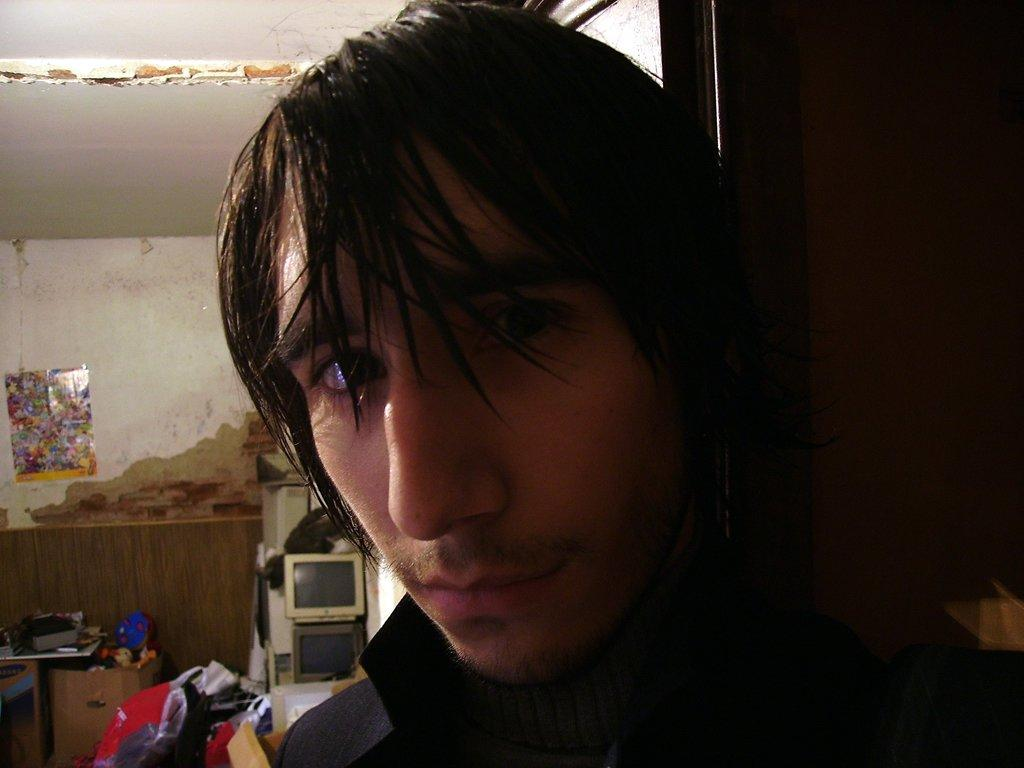Who or what is the main subject in the image? There is a person in the image. What can be seen in the background of the image? There are televisions, a cover bag, a table, a wall, a poster, and a roof in the background of the image. Can you describe the objects in the background? A: There are some objects in the background of the image. What is the name of the star that appears in the image? There is no star present in the image. What type of floor can be seen in the image? The facts provided do not mention the floor, so we cannot determine its type from the image. 